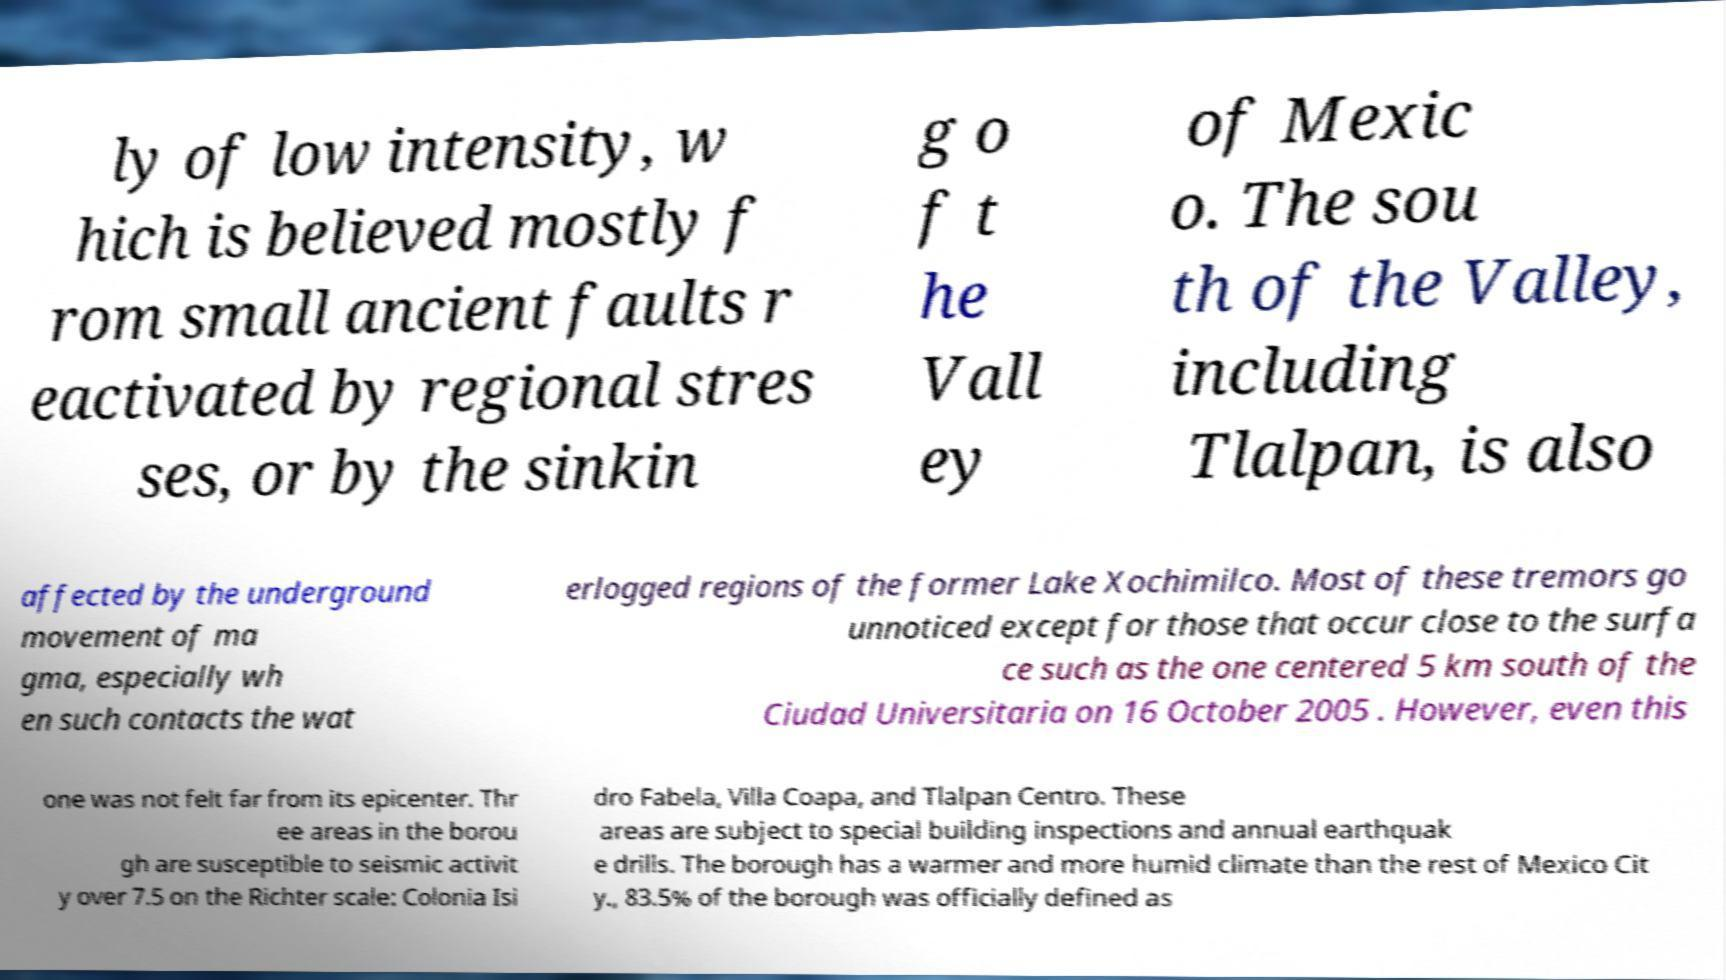I need the written content from this picture converted into text. Can you do that? ly of low intensity, w hich is believed mostly f rom small ancient faults r eactivated by regional stres ses, or by the sinkin g o f t he Vall ey of Mexic o. The sou th of the Valley, including Tlalpan, is also affected by the underground movement of ma gma, especially wh en such contacts the wat erlogged regions of the former Lake Xochimilco. Most of these tremors go unnoticed except for those that occur close to the surfa ce such as the one centered 5 km south of the Ciudad Universitaria on 16 October 2005 . However, even this one was not felt far from its epicenter. Thr ee areas in the borou gh are susceptible to seismic activit y over 7.5 on the Richter scale: Colonia Isi dro Fabela, Villa Coapa, and Tlalpan Centro. These areas are subject to special building inspections and annual earthquak e drills. The borough has a warmer and more humid climate than the rest of Mexico Cit y., 83.5% of the borough was officially defined as 